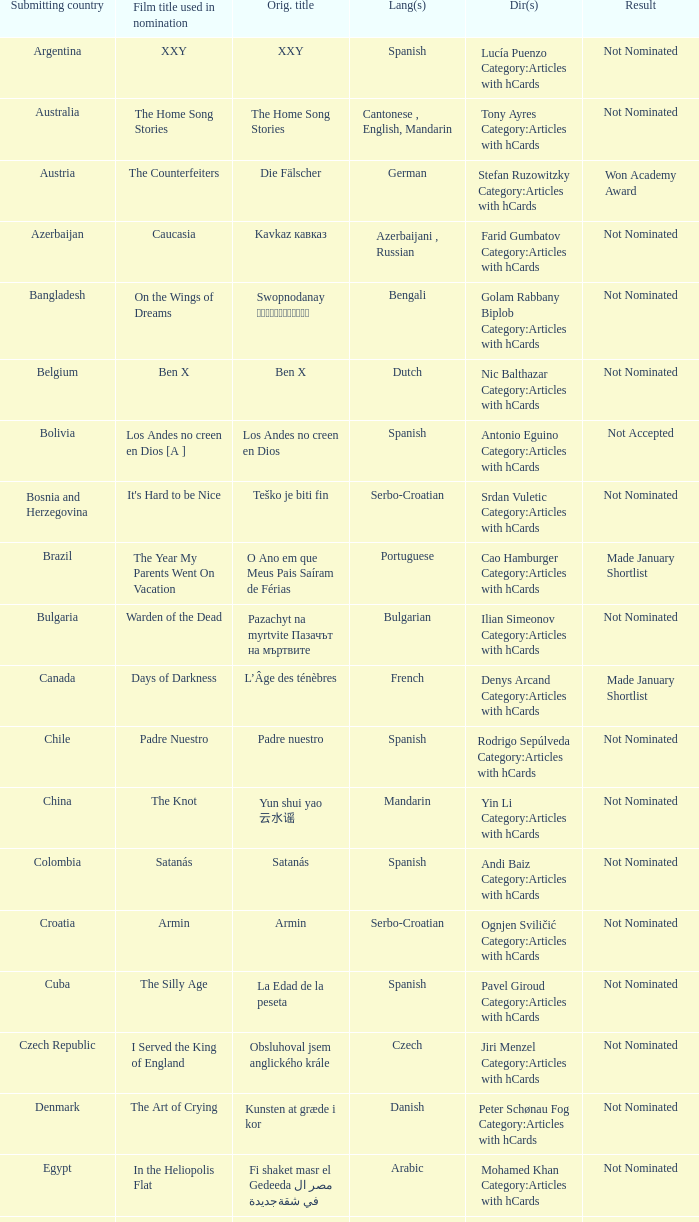What was the title of the movie from lebanon? Caramel. 